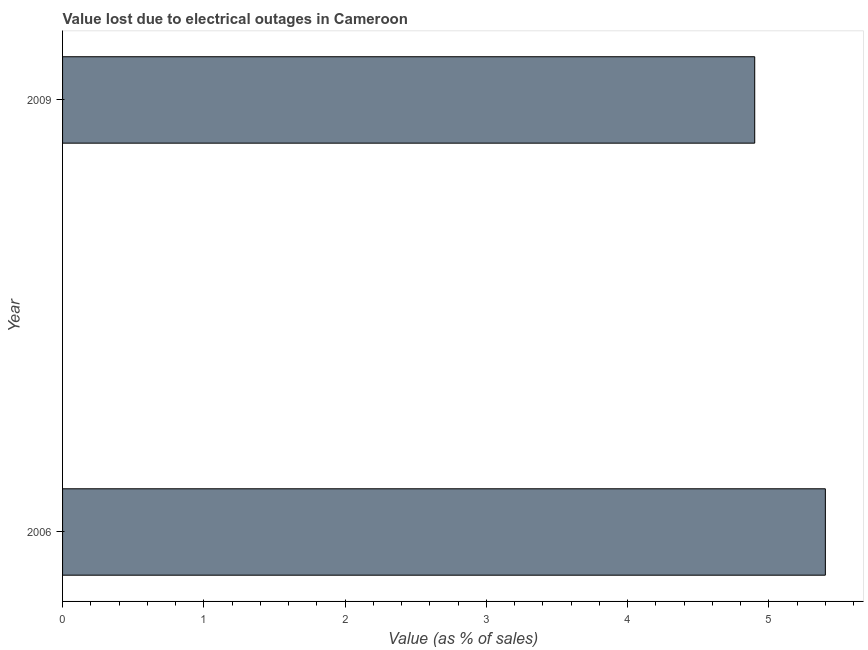Does the graph contain grids?
Offer a terse response. No. What is the title of the graph?
Your answer should be compact. Value lost due to electrical outages in Cameroon. What is the label or title of the X-axis?
Your answer should be compact. Value (as % of sales). What is the label or title of the Y-axis?
Provide a short and direct response. Year. What is the sum of the value lost due to electrical outages?
Your response must be concise. 10.3. What is the average value lost due to electrical outages per year?
Ensure brevity in your answer.  5.15. What is the median value lost due to electrical outages?
Your answer should be compact. 5.15. In how many years, is the value lost due to electrical outages greater than 3.6 %?
Provide a succinct answer. 2. What is the ratio of the value lost due to electrical outages in 2006 to that in 2009?
Give a very brief answer. 1.1. In how many years, is the value lost due to electrical outages greater than the average value lost due to electrical outages taken over all years?
Make the answer very short. 1. How many bars are there?
Keep it short and to the point. 2. How many years are there in the graph?
Your answer should be very brief. 2. What is the difference between two consecutive major ticks on the X-axis?
Keep it short and to the point. 1. Are the values on the major ticks of X-axis written in scientific E-notation?
Your answer should be very brief. No. What is the Value (as % of sales) in 2009?
Ensure brevity in your answer.  4.9. What is the difference between the Value (as % of sales) in 2006 and 2009?
Make the answer very short. 0.5. What is the ratio of the Value (as % of sales) in 2006 to that in 2009?
Provide a succinct answer. 1.1. 